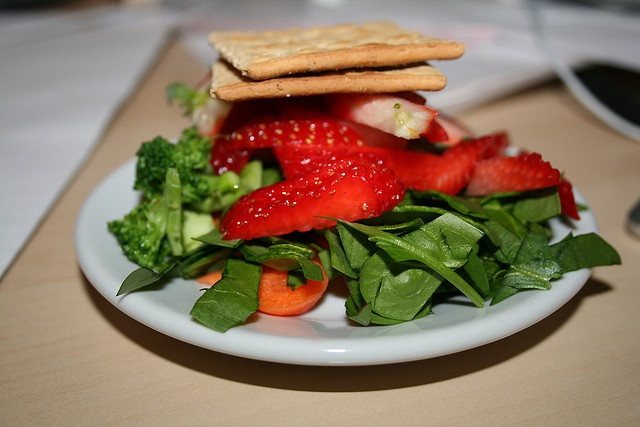Describe the objects in this image and their specific colors. I can see dining table in black and tan tones, broccoli in black, darkgreen, and olive tones, carrot in black, red, brown, and darkgreen tones, and carrot in black, red, brown, maroon, and salmon tones in this image. 